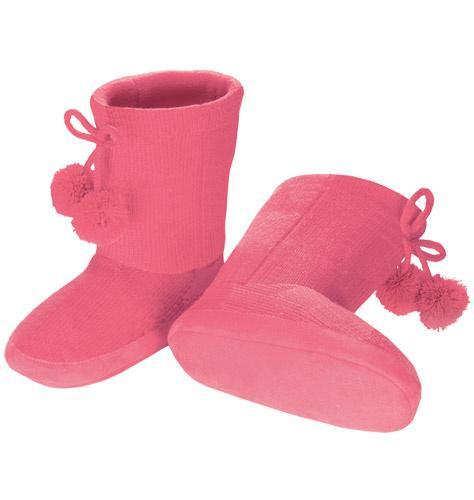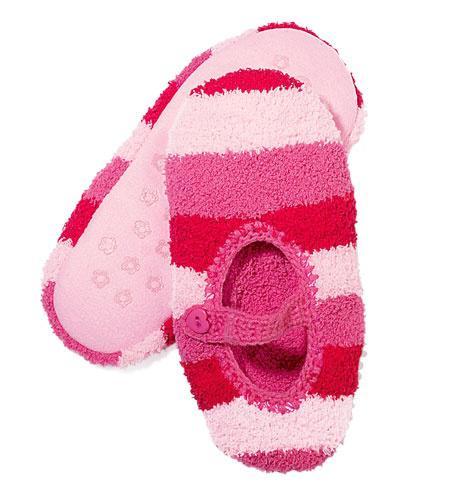The first image is the image on the left, the second image is the image on the right. Given the left and right images, does the statement "The left image features a slipper style with an animal face on the top, and the right image shows a matching pair of fur-trimmed slippers." hold true? Answer yes or no. No. The first image is the image on the left, the second image is the image on the right. Given the left and right images, does the statement "Two pairs of slippers are pink, but different styles, one of them a solid pink color with same color furry trim element." hold true? Answer yes or no. Yes. 